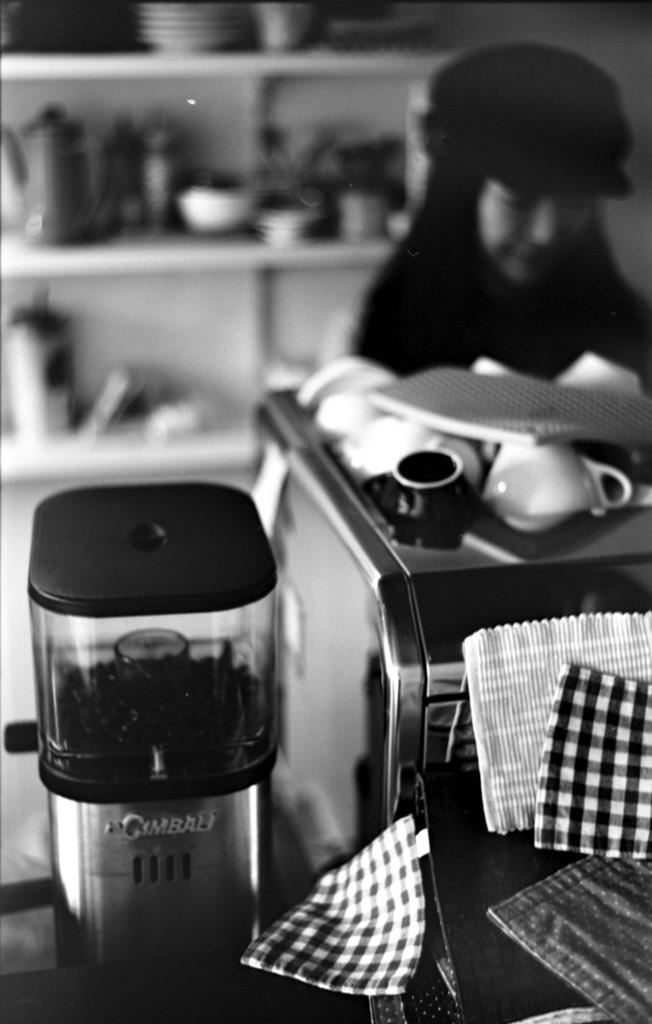Provide a one-sentence caption for the provided image. an item that has Gimbali written on it. 